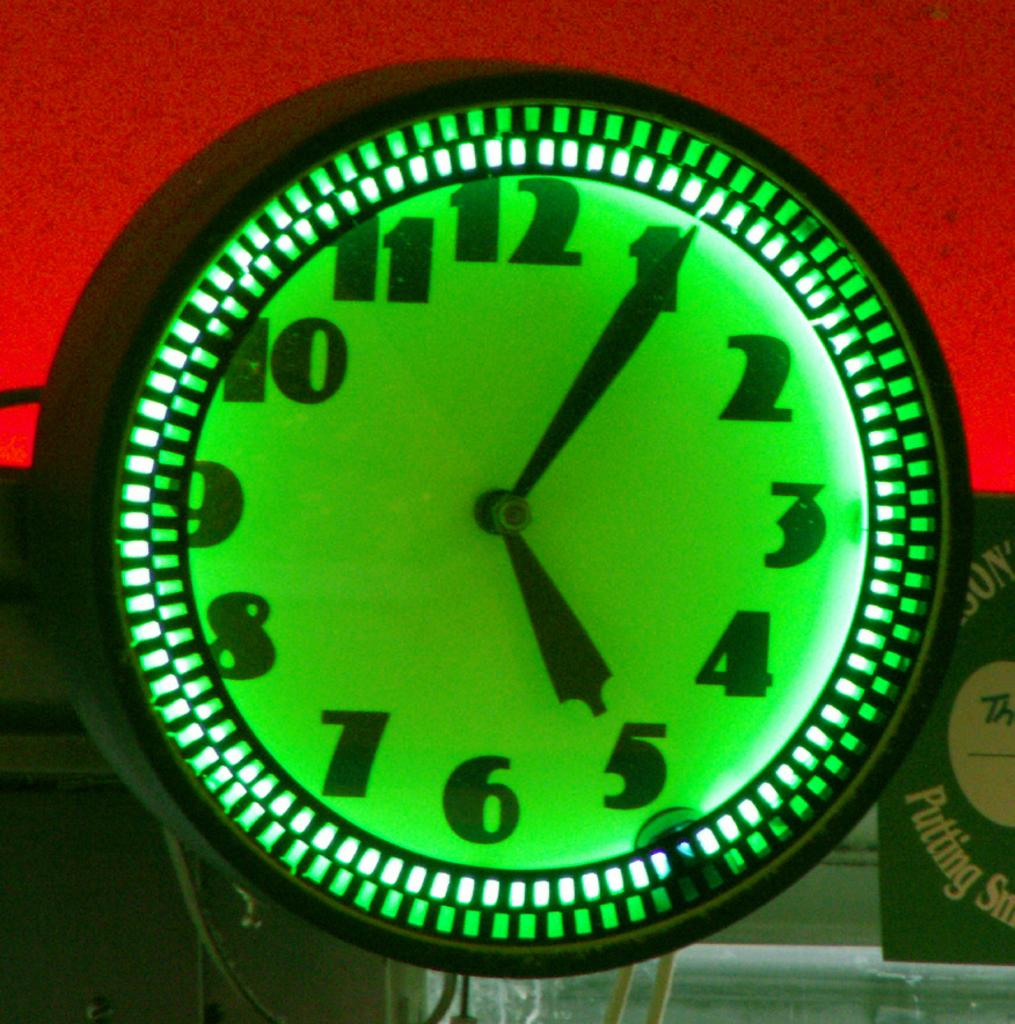<image>
Write a terse but informative summary of the picture. A bright green clock face shows that it is six minutes after five. 